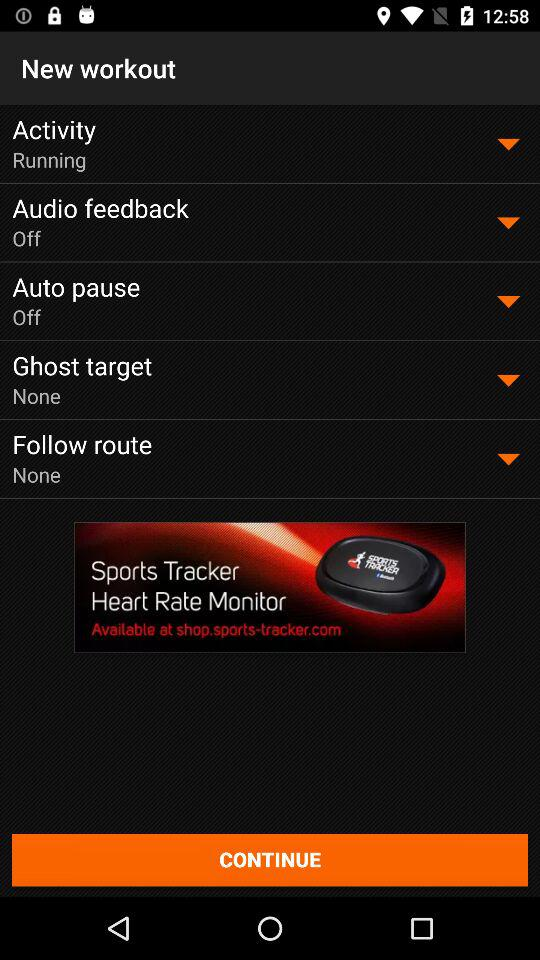What setting has the running option chosen? The setting for the running option is activity. 